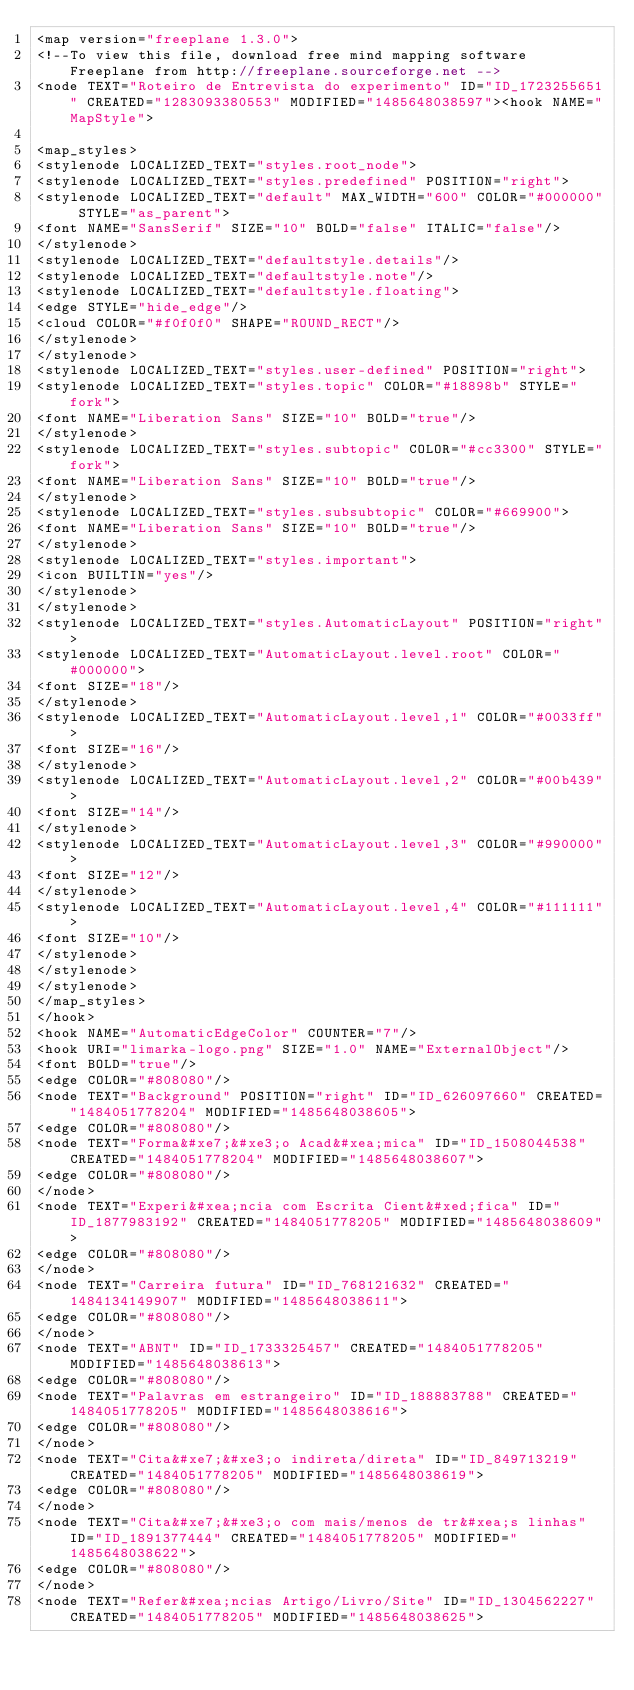Convert code to text. <code><loc_0><loc_0><loc_500><loc_500><_ObjectiveC_><map version="freeplane 1.3.0">
<!--To view this file, download free mind mapping software Freeplane from http://freeplane.sourceforge.net -->
<node TEXT="Roteiro de Entrevista do experimento" ID="ID_1723255651" CREATED="1283093380553" MODIFIED="1485648038597"><hook NAME="MapStyle">

<map_styles>
<stylenode LOCALIZED_TEXT="styles.root_node">
<stylenode LOCALIZED_TEXT="styles.predefined" POSITION="right">
<stylenode LOCALIZED_TEXT="default" MAX_WIDTH="600" COLOR="#000000" STYLE="as_parent">
<font NAME="SansSerif" SIZE="10" BOLD="false" ITALIC="false"/>
</stylenode>
<stylenode LOCALIZED_TEXT="defaultstyle.details"/>
<stylenode LOCALIZED_TEXT="defaultstyle.note"/>
<stylenode LOCALIZED_TEXT="defaultstyle.floating">
<edge STYLE="hide_edge"/>
<cloud COLOR="#f0f0f0" SHAPE="ROUND_RECT"/>
</stylenode>
</stylenode>
<stylenode LOCALIZED_TEXT="styles.user-defined" POSITION="right">
<stylenode LOCALIZED_TEXT="styles.topic" COLOR="#18898b" STYLE="fork">
<font NAME="Liberation Sans" SIZE="10" BOLD="true"/>
</stylenode>
<stylenode LOCALIZED_TEXT="styles.subtopic" COLOR="#cc3300" STYLE="fork">
<font NAME="Liberation Sans" SIZE="10" BOLD="true"/>
</stylenode>
<stylenode LOCALIZED_TEXT="styles.subsubtopic" COLOR="#669900">
<font NAME="Liberation Sans" SIZE="10" BOLD="true"/>
</stylenode>
<stylenode LOCALIZED_TEXT="styles.important">
<icon BUILTIN="yes"/>
</stylenode>
</stylenode>
<stylenode LOCALIZED_TEXT="styles.AutomaticLayout" POSITION="right">
<stylenode LOCALIZED_TEXT="AutomaticLayout.level.root" COLOR="#000000">
<font SIZE="18"/>
</stylenode>
<stylenode LOCALIZED_TEXT="AutomaticLayout.level,1" COLOR="#0033ff">
<font SIZE="16"/>
</stylenode>
<stylenode LOCALIZED_TEXT="AutomaticLayout.level,2" COLOR="#00b439">
<font SIZE="14"/>
</stylenode>
<stylenode LOCALIZED_TEXT="AutomaticLayout.level,3" COLOR="#990000">
<font SIZE="12"/>
</stylenode>
<stylenode LOCALIZED_TEXT="AutomaticLayout.level,4" COLOR="#111111">
<font SIZE="10"/>
</stylenode>
</stylenode>
</stylenode>
</map_styles>
</hook>
<hook NAME="AutomaticEdgeColor" COUNTER="7"/>
<hook URI="limarka-logo.png" SIZE="1.0" NAME="ExternalObject"/>
<font BOLD="true"/>
<edge COLOR="#808080"/>
<node TEXT="Background" POSITION="right" ID="ID_626097660" CREATED="1484051778204" MODIFIED="1485648038605">
<edge COLOR="#808080"/>
<node TEXT="Forma&#xe7;&#xe3;o Acad&#xea;mica" ID="ID_1508044538" CREATED="1484051778204" MODIFIED="1485648038607">
<edge COLOR="#808080"/>
</node>
<node TEXT="Experi&#xea;ncia com Escrita Cient&#xed;fica" ID="ID_1877983192" CREATED="1484051778205" MODIFIED="1485648038609">
<edge COLOR="#808080"/>
</node>
<node TEXT="Carreira futura" ID="ID_768121632" CREATED="1484134149907" MODIFIED="1485648038611">
<edge COLOR="#808080"/>
</node>
<node TEXT="ABNT" ID="ID_1733325457" CREATED="1484051778205" MODIFIED="1485648038613">
<edge COLOR="#808080"/>
<node TEXT="Palavras em estrangeiro" ID="ID_188883788" CREATED="1484051778205" MODIFIED="1485648038616">
<edge COLOR="#808080"/>
</node>
<node TEXT="Cita&#xe7;&#xe3;o indireta/direta" ID="ID_849713219" CREATED="1484051778205" MODIFIED="1485648038619">
<edge COLOR="#808080"/>
</node>
<node TEXT="Cita&#xe7;&#xe3;o com mais/menos de tr&#xea;s linhas" ID="ID_1891377444" CREATED="1484051778205" MODIFIED="1485648038622">
<edge COLOR="#808080"/>
</node>
<node TEXT="Refer&#xea;ncias Artigo/Livro/Site" ID="ID_1304562227" CREATED="1484051778205" MODIFIED="1485648038625"></code> 